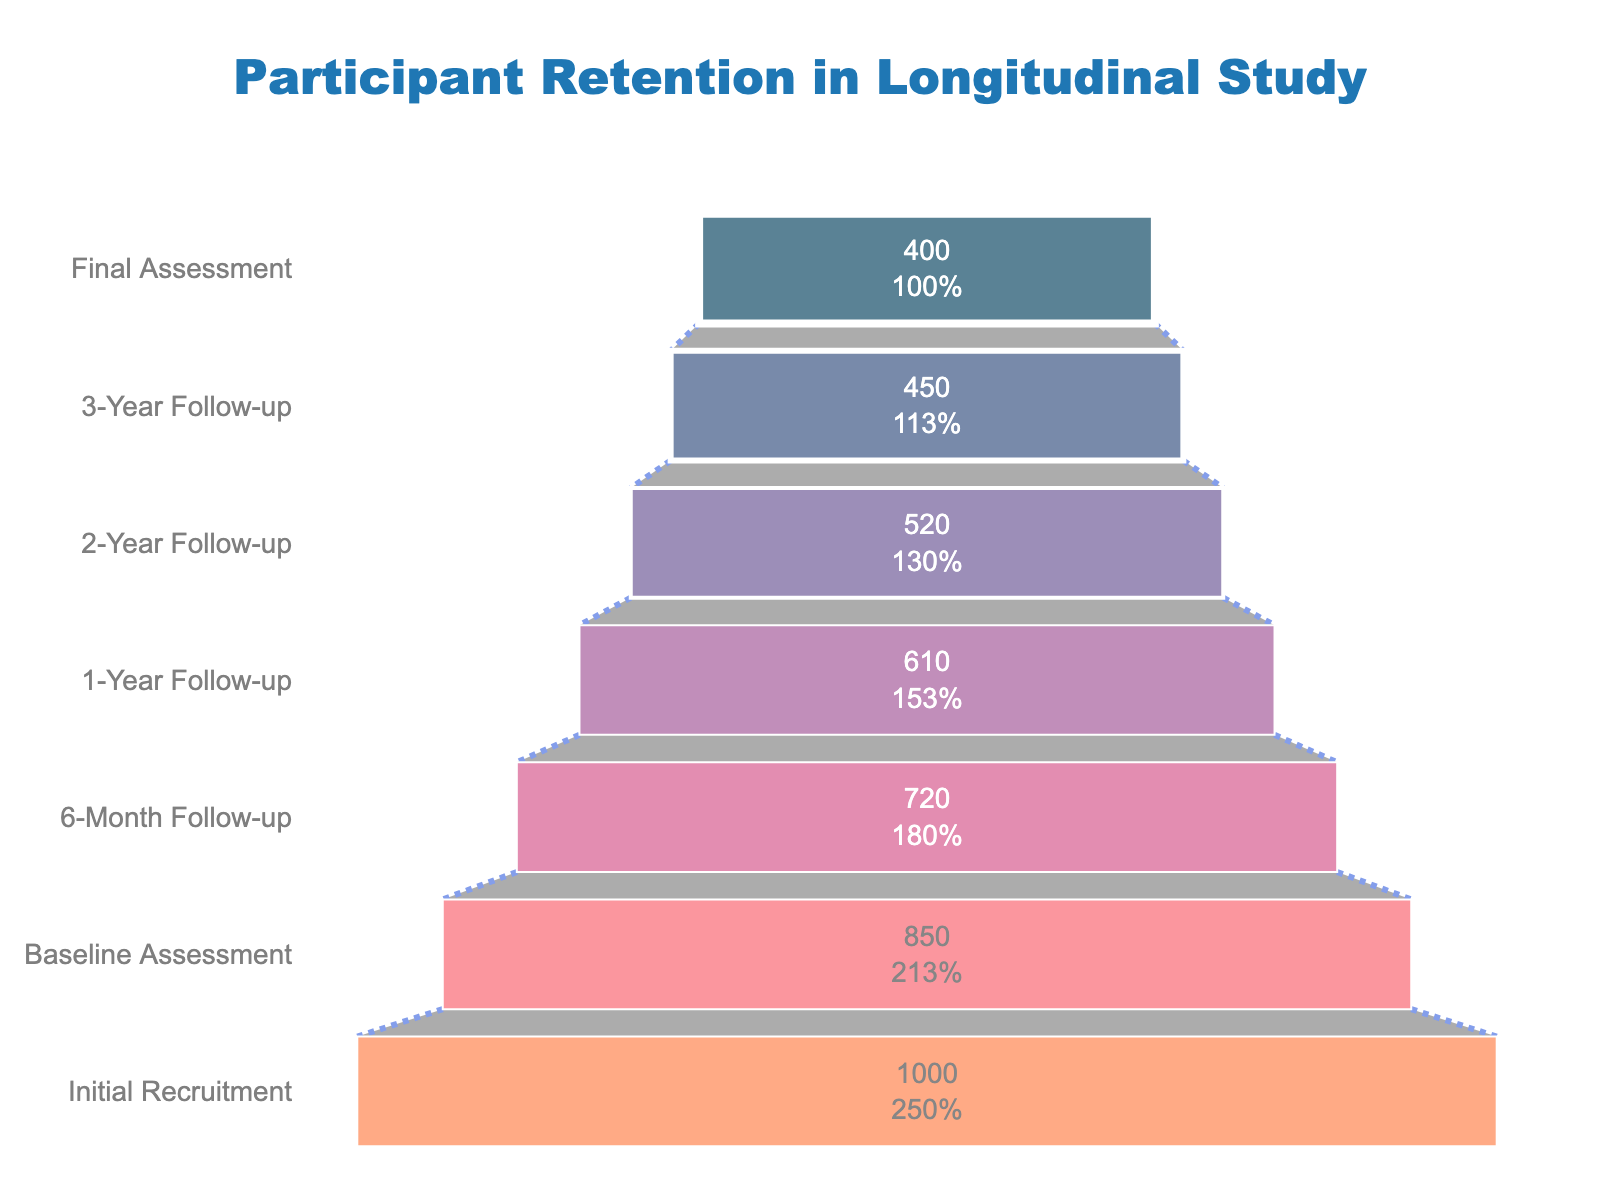What is the title of the plot? The title of the plot is located at the top center of the figure and is displayed with a specific font style and size, making it easily identifiable.
Answer: Participant Retention in Longitudinal Study How many participants completed the Final Assessment? The funnel chart displays the number of participants at each stage, including the Final Assessment. This value is shown at the very bottom of the funnel.
Answer: 400 Which stage has the largest drop in participants from the previous stage? By observing the differences in participant numbers between consecutive stages, the largest drop can be identified. It involves calculating the decrease in participants from one stage to the next.
Answer: Baseline Assessment to 6-Month Follow-up What percentage of participants from the Initial Recruitment stage completed the 3-Year Follow-up stage? To find this percentage, you need to divide the number of participants at the 3-Year Follow-up stage by the number of participants at the Initial Recruitment stage, then multiply by 100.
Answer: 45% How many total participants were lost from the Initial Recruitment to the Final Assessment? The total loss in participants can be found by subtracting the number of participants at the Final Assessment stage from the number of participants at the Initial Recruitment stage.
Answer: 600 Compare the participant retention between the 1-Year Follow-up and the 2-Year Follow-up stages. Which stage retained more participants? By comparing the participant numbers for the 1-Year Follow-up and the 2-Year Follow-up stages directly, the stage with the higher number can be identified.
Answer: 1-Year Follow-up What is the trend observed in the participant retention across the stages? The funnel chart provides a visual representation of participant numbers diminishing over time across each stage. Observing the shape and flow of the funnel reveals the overall trend.
Answer: Decreasing Trend Calculate the average number of participants remaining after each follow-up assessment (excluding the Initial Recruitment). To find the average, sum the number of participants at each follow-up stage (Baseline, 6-Month, 1-Year, 2-Year, 3-Year, and Final Assessment) and divide by the number of follow-up stages.
Answer: 591.67 What is the visual indicator used to connect the stages in the funnel chart? The visual indicator for connecting stages in the funnel chart is a specific line style, which can be identified by observing the connections between each stage.
Answer: Dotted line 